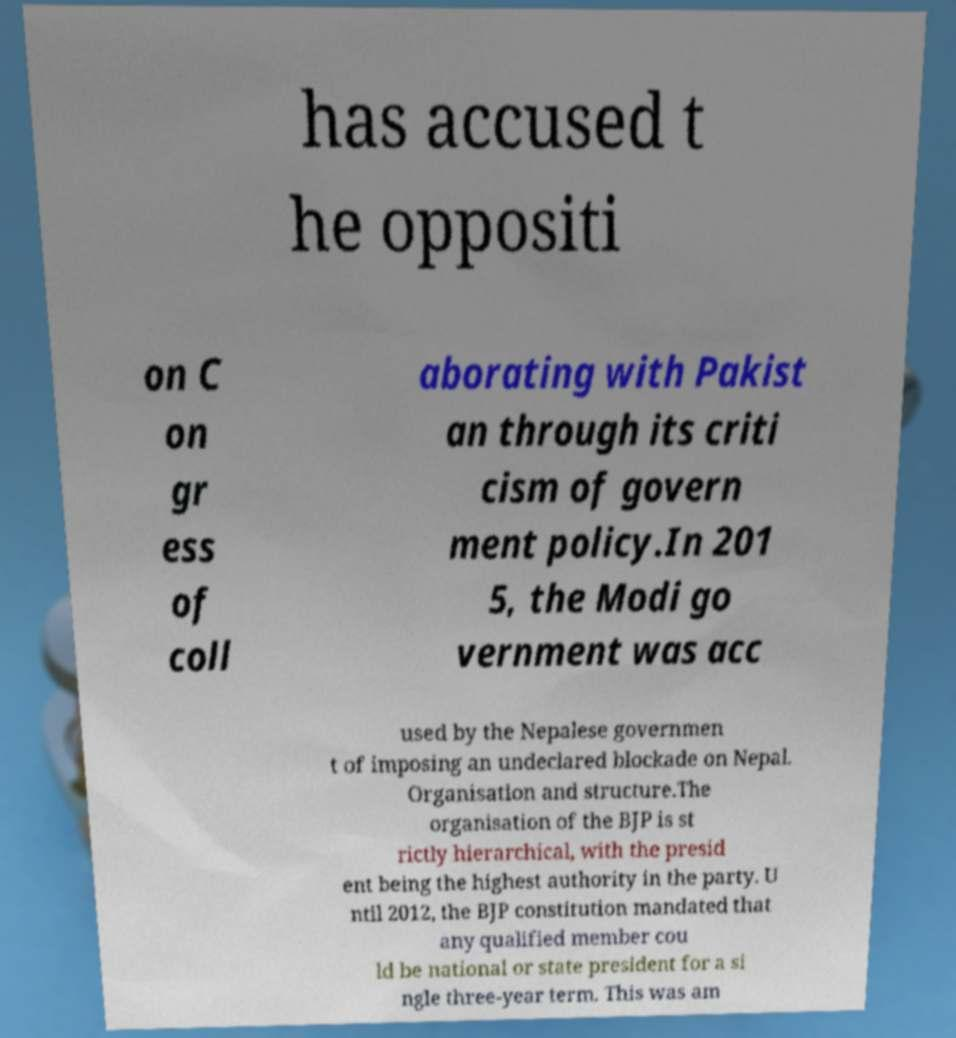Can you accurately transcribe the text from the provided image for me? has accused t he oppositi on C on gr ess of coll aborating with Pakist an through its criti cism of govern ment policy.In 201 5, the Modi go vernment was acc used by the Nepalese governmen t of imposing an undeclared blockade on Nepal. Organisation and structure.The organisation of the BJP is st rictly hierarchical, with the presid ent being the highest authority in the party. U ntil 2012, the BJP constitution mandated that any qualified member cou ld be national or state president for a si ngle three-year term. This was am 